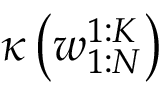Convert formula to latex. <formula><loc_0><loc_0><loc_500><loc_500>\kappa \left ( w _ { 1 \colon N } ^ { 1 \colon K } \right )</formula> 